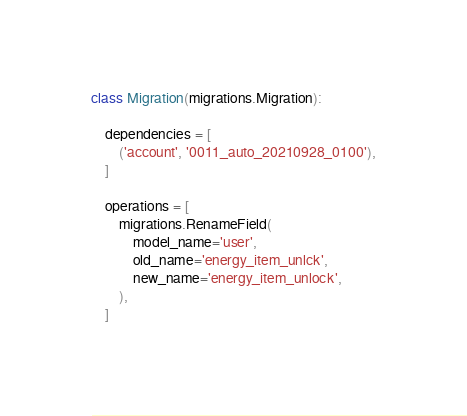Convert code to text. <code><loc_0><loc_0><loc_500><loc_500><_Python_>class Migration(migrations.Migration):

    dependencies = [
        ('account', '0011_auto_20210928_0100'),
    ]

    operations = [
        migrations.RenameField(
            model_name='user',
            old_name='energy_item_unlck',
            new_name='energy_item_unlock',
        ),
    ]
</code> 